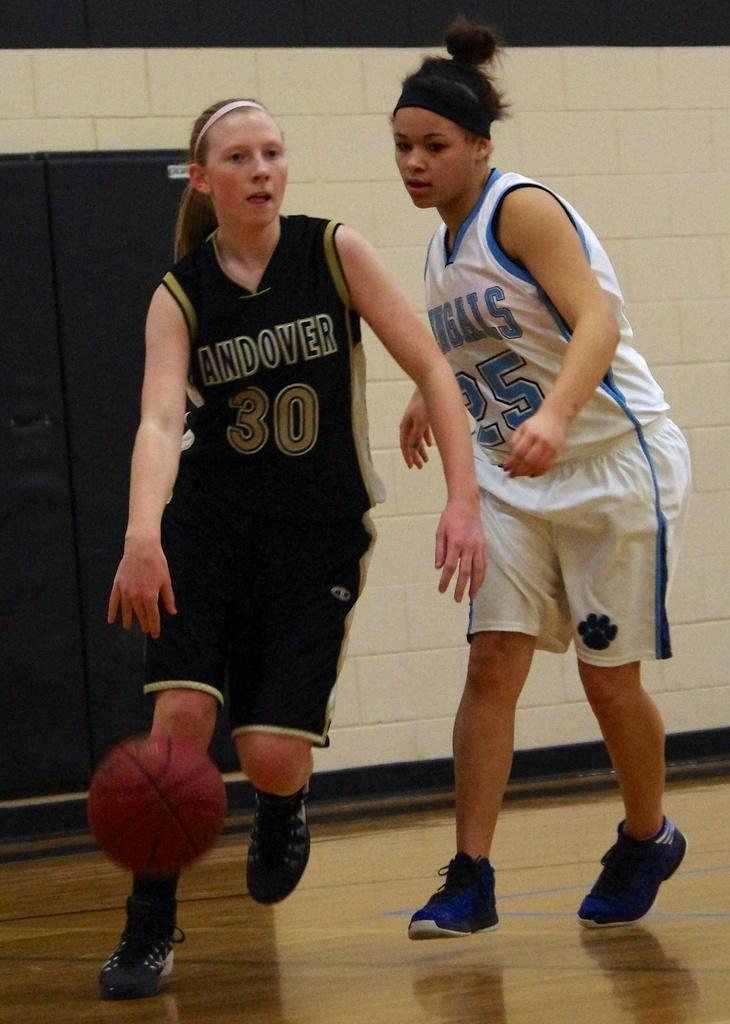Provide a one-sentence caption for the provided image. The basketball player with the ball is from Andover. 